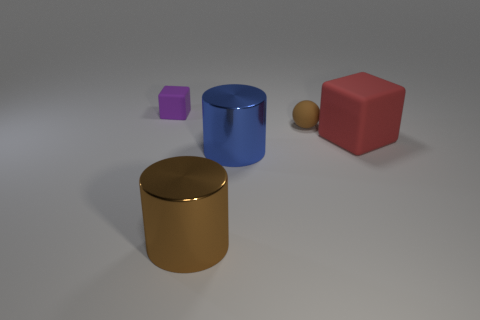Are there any other red things that have the same shape as the red matte thing?
Offer a terse response. No. Are there the same number of metallic cylinders right of the big blue object and big blue metal objects?
Your response must be concise. No. What is the material of the big red object that is in front of the tiny rubber thing to the right of the purple matte cube?
Your answer should be compact. Rubber. What is the shape of the brown matte thing?
Make the answer very short. Sphere. Are there an equal number of big red matte cubes that are in front of the large blue object and red matte objects that are in front of the tiny brown matte thing?
Provide a succinct answer. No. Is the color of the matte cube that is behind the red rubber thing the same as the matte block to the right of the big brown object?
Provide a succinct answer. No. Are there more big matte blocks in front of the big matte thing than large brown things?
Your answer should be very brief. No. What is the shape of the tiny object that is made of the same material as the purple block?
Your answer should be compact. Sphere. Does the shiny cylinder that is in front of the blue cylinder have the same size as the tiny matte cube?
Provide a short and direct response. No. The small thing that is to the left of the metal thing that is to the left of the big blue metallic cylinder is what shape?
Offer a very short reply. Cube. 